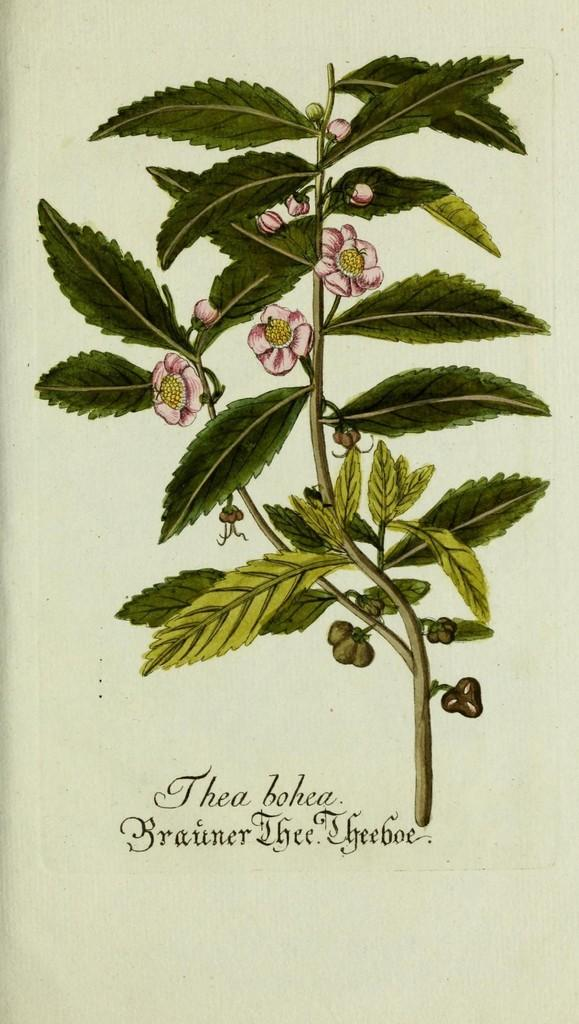What is the main subject of the picture? The main subject of the picture is a printed image of a plant with flowers. What else can be seen at the bottom of the picture? There is text at the bottom of the picture. What color is the background of the picture? The background of the picture is white. What is the size of the plant in the picture? The size of the plant in the picture cannot be determined from the image alone, as it is a printed image and not a photograph. 